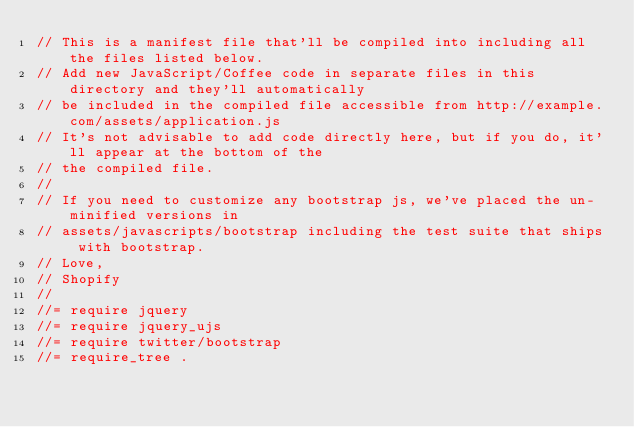Convert code to text. <code><loc_0><loc_0><loc_500><loc_500><_JavaScript_>// This is a manifest file that'll be compiled into including all the files listed below.
// Add new JavaScript/Coffee code in separate files in this directory and they'll automatically
// be included in the compiled file accessible from http://example.com/assets/application.js
// It's not advisable to add code directly here, but if you do, it'll appear at the bottom of the
// the compiled file.
//
// If you need to customize any bootstrap js, we've placed the un-minified versions in
// assets/javascripts/bootstrap including the test suite that ships with bootstrap.
// Love,
// Shopify
//
//= require jquery
//= require jquery_ujs
//= require twitter/bootstrap
//= require_tree .</code> 